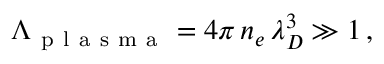Convert formula to latex. <formula><loc_0><loc_0><loc_500><loc_500>\Lambda _ { p l a s m a } = 4 \pi \, n _ { e } \, \lambda _ { D } ^ { 3 } \gg 1 \, ,</formula> 